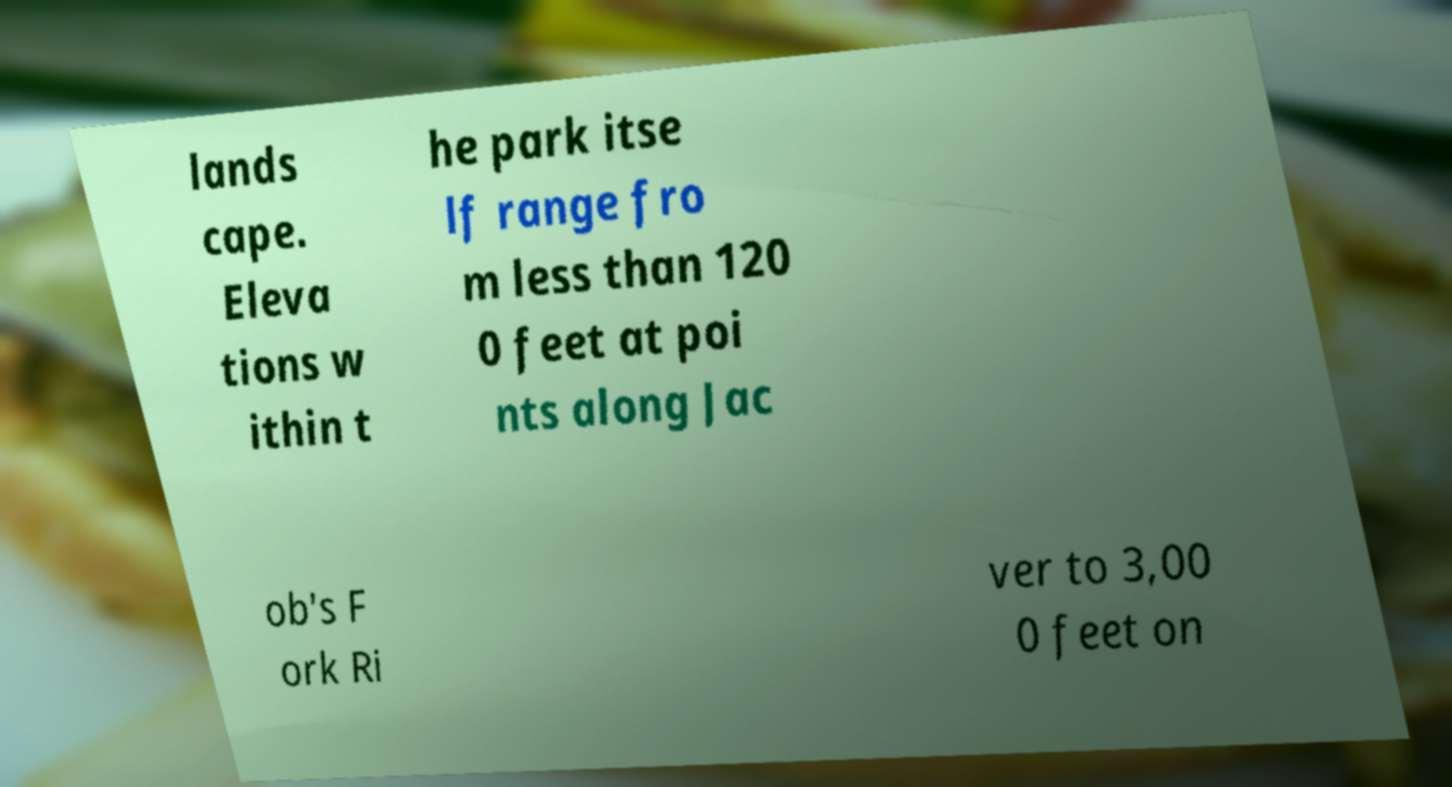Please read and relay the text visible in this image. What does it say? lands cape. Eleva tions w ithin t he park itse lf range fro m less than 120 0 feet at poi nts along Jac ob's F ork Ri ver to 3,00 0 feet on 